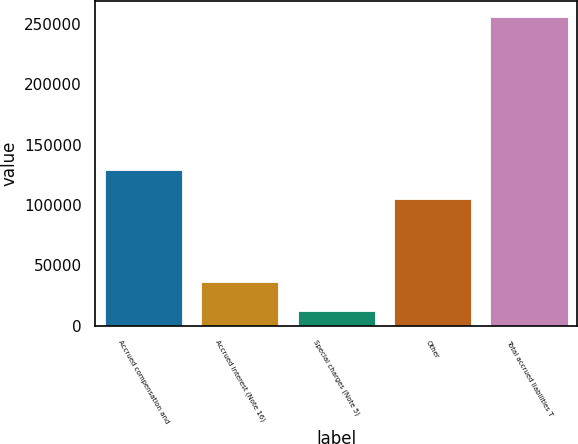Convert chart to OTSL. <chart><loc_0><loc_0><loc_500><loc_500><bar_chart><fcel>Accrued compensation and<fcel>Accrued interest (Note 16)<fcel>Special charges (Note 5)<fcel>Other<fcel>Total accrued liabilities T<nl><fcel>129417<fcel>36722.3<fcel>12374<fcel>105069<fcel>255857<nl></chart> 